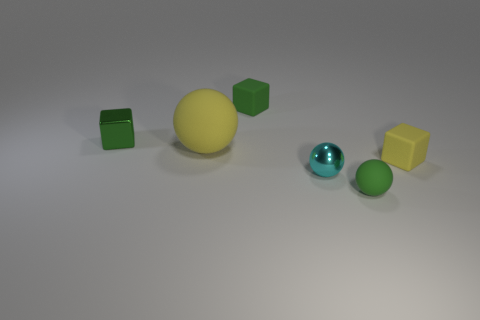Subtract all green cubes. How many were subtracted if there are1green cubes left? 1 Subtract 0 cyan cylinders. How many objects are left? 6 Subtract 3 blocks. How many blocks are left? 0 Subtract all cyan spheres. Subtract all cyan blocks. How many spheres are left? 2 Subtract all cyan spheres. How many brown cubes are left? 0 Subtract all tiny brown matte cubes. Subtract all yellow matte objects. How many objects are left? 4 Add 4 cyan things. How many cyan things are left? 5 Add 5 tiny purple metal cylinders. How many tiny purple metal cylinders exist? 5 Add 4 small metal balls. How many objects exist? 10 Subtract all green spheres. How many spheres are left? 2 